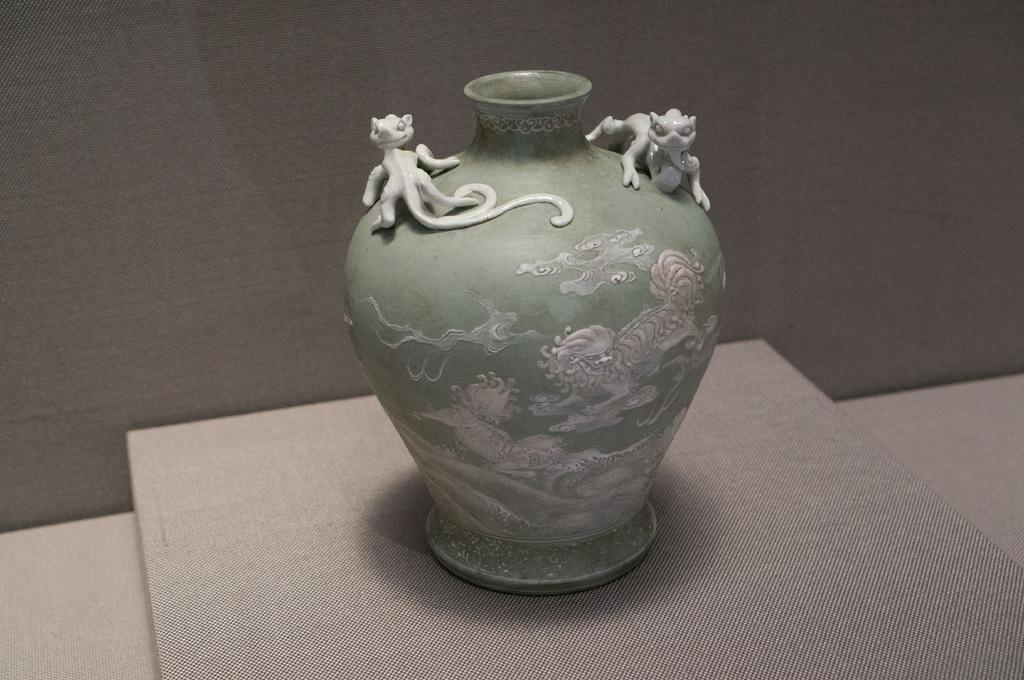What is the color of the background in the image? The background of the image is in grey color. What can be seen in the image besides the background? There is a pot in the image. How is the pot designed? The pot is designed beautifully. Where is the pot placed in the image? The pot is placed on a platform. What type of tramp is visible in the image? There is no tramp present in the image; it features a pot placed on a platform with a grey background. What role does the army play in the image? There is no mention of the army in the image; it only shows a pot and a grey background. 